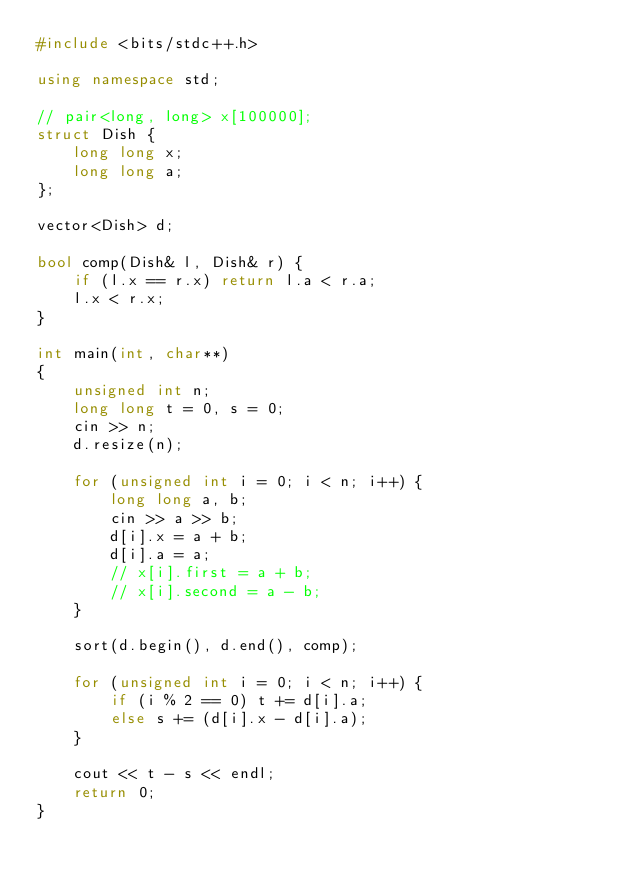<code> <loc_0><loc_0><loc_500><loc_500><_C++_>#include <bits/stdc++.h>

using namespace std;

// pair<long, long> x[100000];
struct Dish {
	long long x;
	long long a;
};

vector<Dish> d;

bool comp(Dish& l, Dish& r) {
	if (l.x == r.x) return l.a < r.a;
	l.x < r.x;
}

int main(int, char**)
{
	unsigned int n;
	long long t = 0, s = 0;
	cin >> n;
	d.resize(n);

	for (unsigned int i = 0; i < n; i++) {
		long long a, b;
		cin >> a >> b;
		d[i].x = a + b;
		d[i].a = a;
		// x[i].first = a + b;
		// x[i].second = a - b;
	}

	sort(d.begin(), d.end(), comp);

	for (unsigned int i = 0; i < n; i++) {
		if (i % 2 == 0) t += d[i].a;
		else s += (d[i].x - d[i].a);
	}

	cout << t - s << endl;
	return 0;
}
</code> 